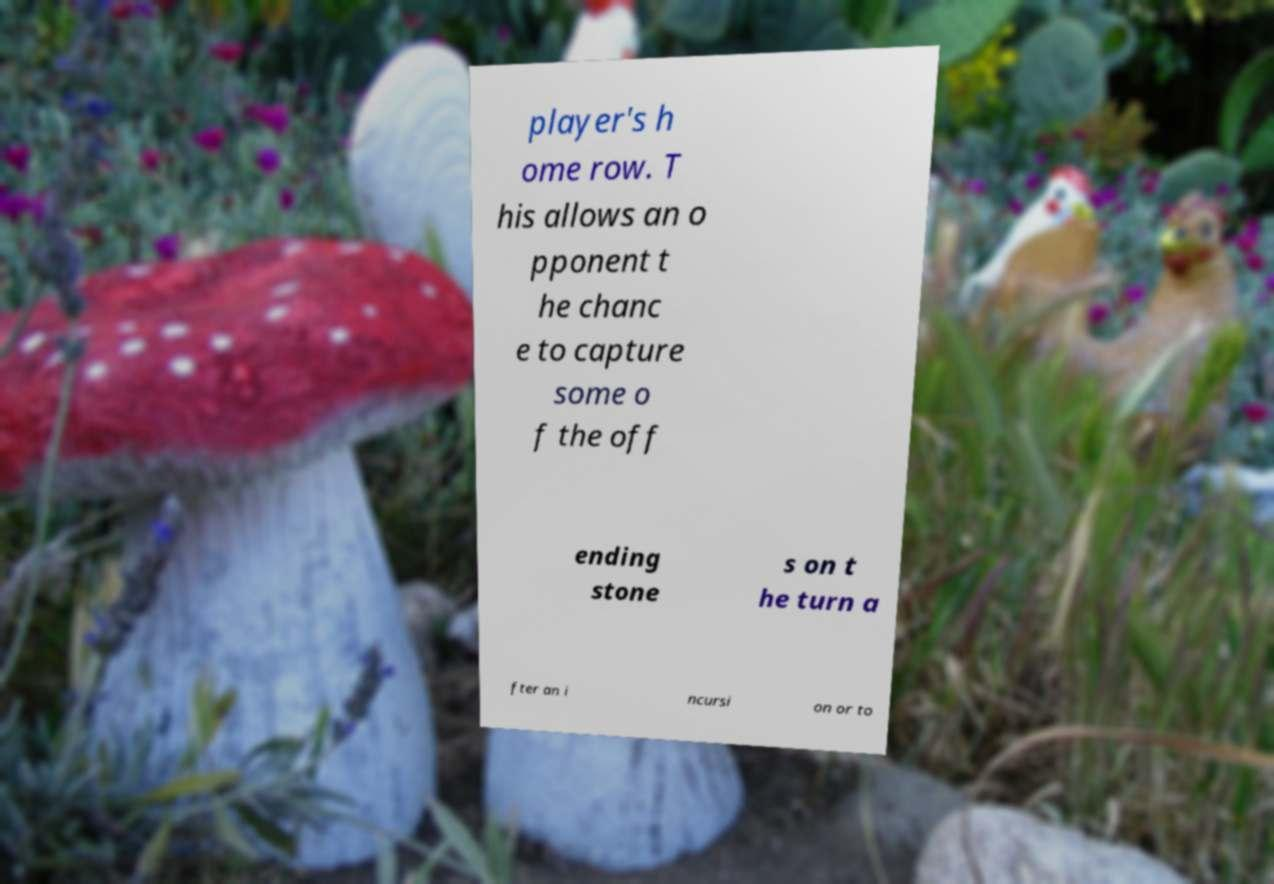For documentation purposes, I need the text within this image transcribed. Could you provide that? player's h ome row. T his allows an o pponent t he chanc e to capture some o f the off ending stone s on t he turn a fter an i ncursi on or to 